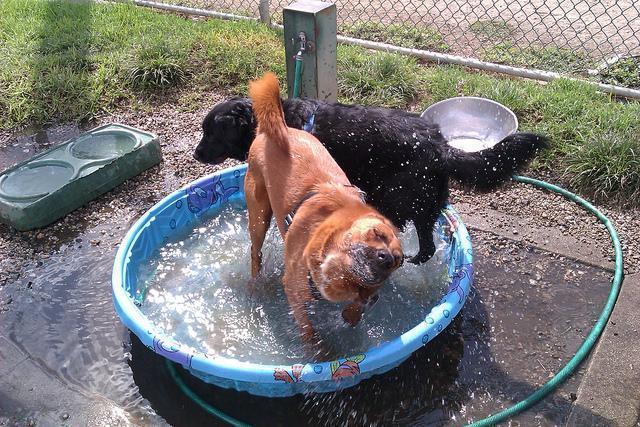What color is the garden hose wrapped around the kiddie pool?
Pick the right solution, then justify: 'Answer: answer
Rationale: rationale.'
Options: Turquoise, purple, red, green. Answer: turquoise.
Rationale: The color is turquoise. 